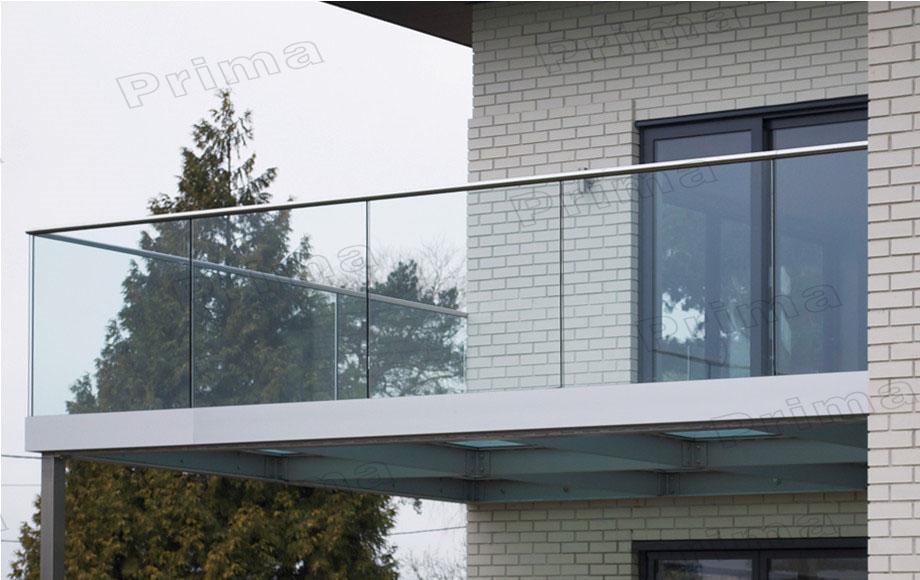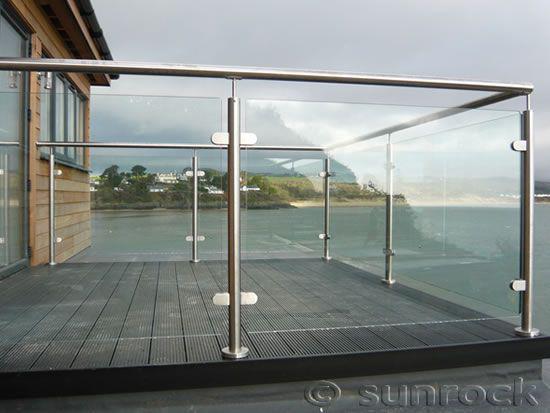The first image is the image on the left, the second image is the image on the right. Considering the images on both sides, is "there is a wooden deck with glass surrounding it, overlooking the water" valid? Answer yes or no. Yes. The first image is the image on the left, the second image is the image on the right. For the images shown, is this caption "In one image, a glass-paneled balcony with a 'plank' floor overlooks the ocean on the right." true? Answer yes or no. Yes. 